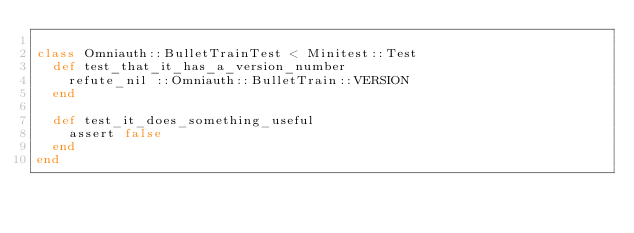<code> <loc_0><loc_0><loc_500><loc_500><_Ruby_>
class Omniauth::BulletTrainTest < Minitest::Test
  def test_that_it_has_a_version_number
    refute_nil ::Omniauth::BulletTrain::VERSION
  end

  def test_it_does_something_useful
    assert false
  end
end
</code> 